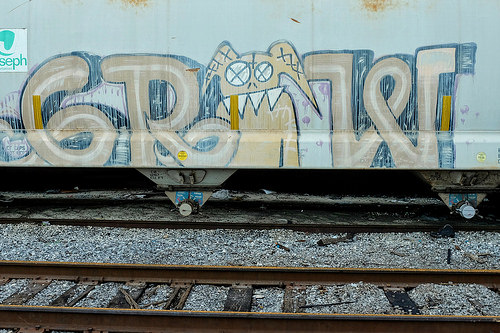<image>
Is there a railway track next to the train? Yes. The railway track is positioned adjacent to the train, located nearby in the same general area. 